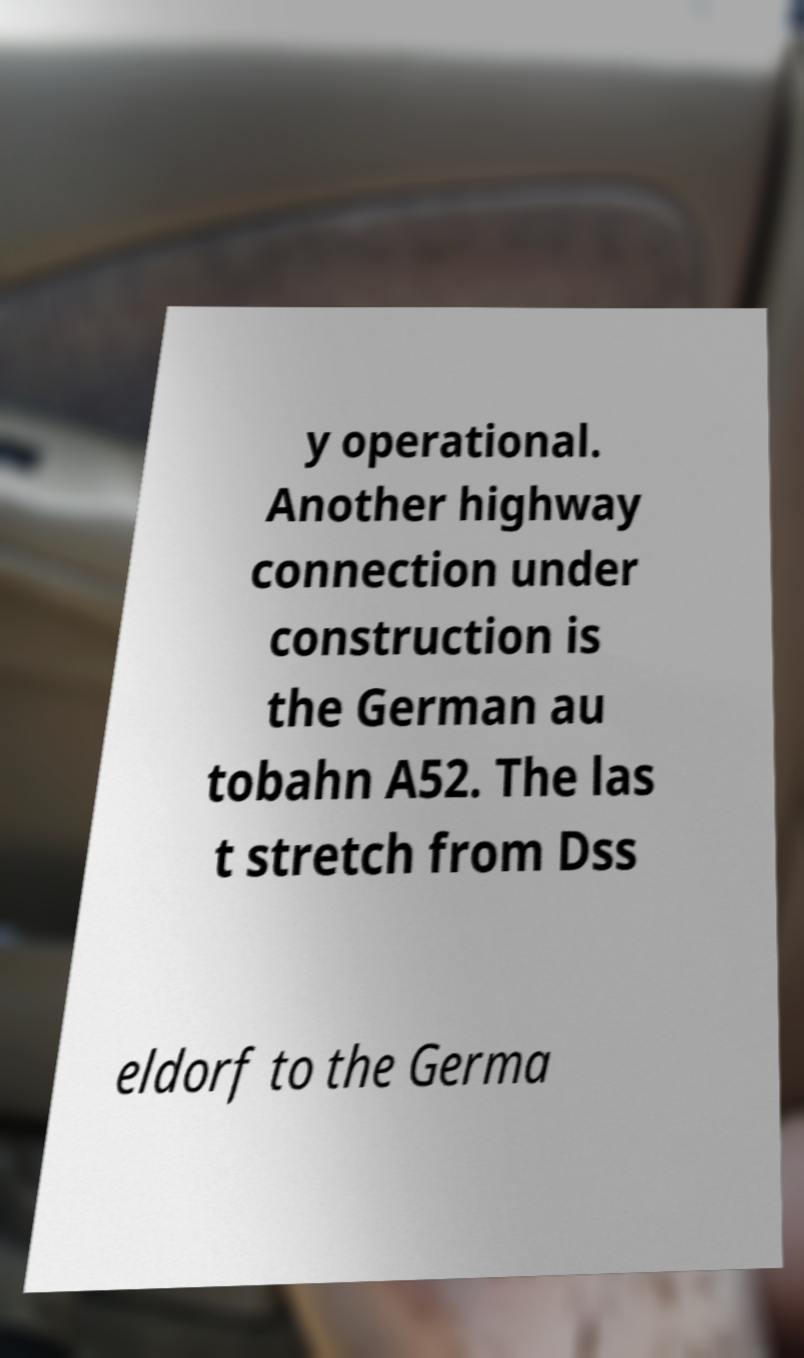Can you read and provide the text displayed in the image?This photo seems to have some interesting text. Can you extract and type it out for me? y operational. Another highway connection under construction is the German au tobahn A52. The las t stretch from Dss eldorf to the Germa 